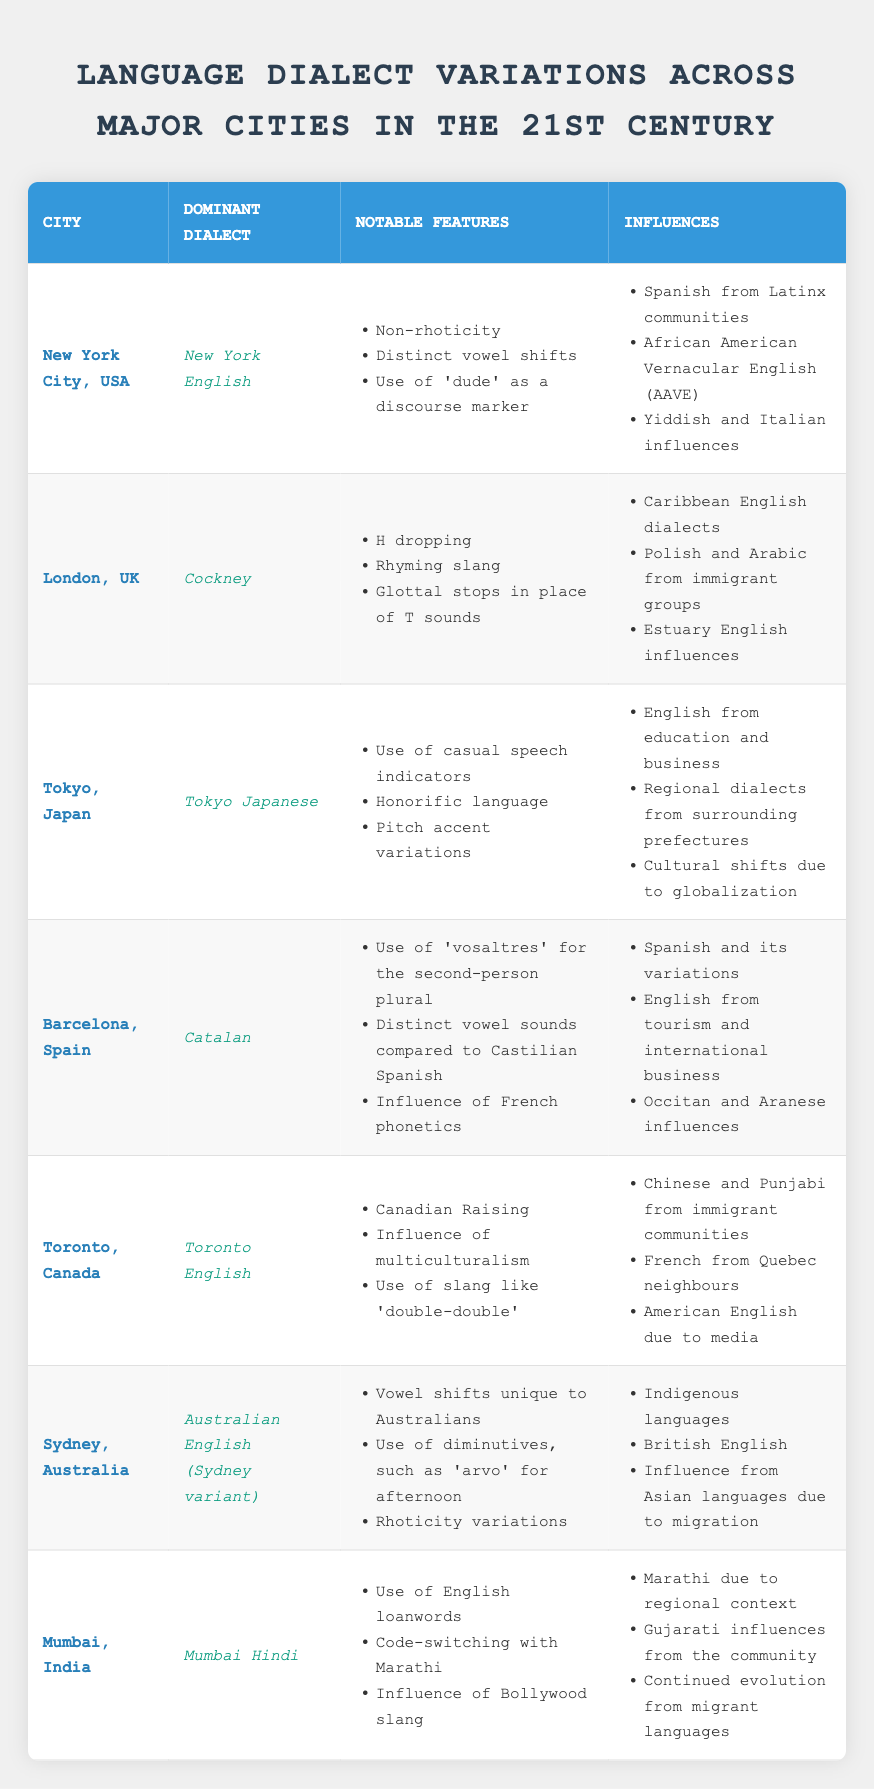What is the dominant dialect of New York City? In the table, under the "Dominant Dialect" column for New York City, the entry states "New York English."
Answer: New York English Which city features 'H dropping' as a notable feature? Looking at the "Notable Features" for the city "London, UK," one of the listed features is "H dropping."
Answer: London, UK How many influential languages are listed for Sydney, Australia? In the "Influences" section for Sydney, there are three items listed: Indigenous languages, British English, and influence from Asian languages.
Answer: Three Does Toronto English include influences from immigrant communities? The data in the "Influences" section for Toronto, Canada, lists "Chinese and Punjabi from immigrant communities," which confirms this fact.
Answer: Yes Which dialect uses 'vosaltres' for the second-person plural? In the table, the dialect for Barcelona is "Catalan," and it explicitly states that the use of 'vosaltres' is a notable feature.
Answer: Catalan Compare the notable features of Tokyo Japanese and Mumbai Hindi; which one includes English loanwords? The notable features of "Tokyo Japanese" do not include English loanwords, while "Mumbai Hindi" lists "Use of English loanwords" as one of its features. Therefore, only Mumbai Hindi includes English loanwords.
Answer: Mumbai Hindi Identify a city where the dominant dialect is influenced by Caribbean English dialects. In the influences for "London, UK," it mentions "Caribbean English dialects," identifying London as that city.
Answer: London, UK What is the average number of notable features across all dialects listed? Listing the notable features per city: New York (3), London (3), Tokyo (3), Barcelona (3), Toronto (3), Sydney (3), and Mumbai (3) gives us a total of 21 features. There are 7 cities, so the average is 21 divided by 7, which is 3.
Answer: 3 Which dialect is influenced by both Spanish and English? In the influences of "Barcelona," it mentions both Spanish and English from tourism and international business, indicating that "Catalan" is influenced by both.
Answer: Catalan What dialect has pitch accent variations as a notable feature? The notable features for "Tokyo, Japan" include "Pitch accent variations." Therefore, Tokyo Japanese has this feature.
Answer: Tokyo Japanese 